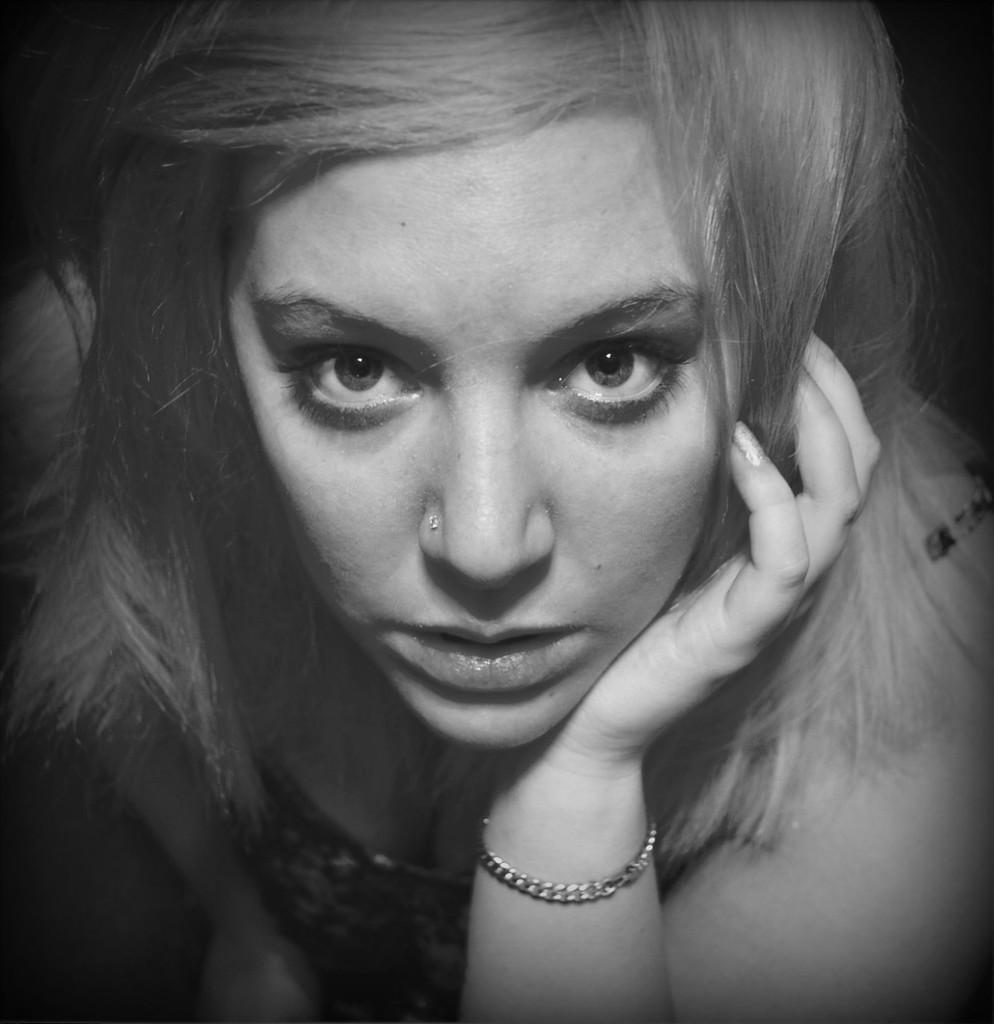Describe this image in one or two sentences. In the foreground of this black and white image, there is a woman. 